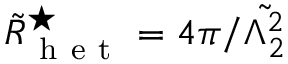<formula> <loc_0><loc_0><loc_500><loc_500>\tilde { R } _ { h e t } ^ { ^ { * } } = 4 \pi / \tilde { \Lambda _ { 2 } ^ { 2 } }</formula> 